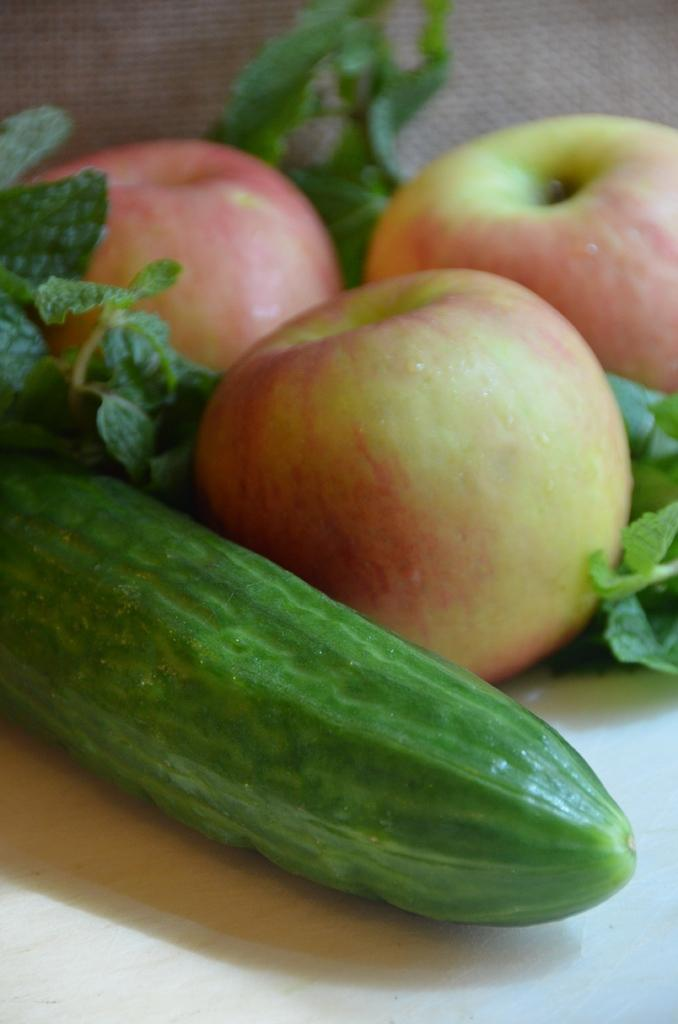What type of fruit can be seen in the image? There are apples in the image. What other type of vegetable is present in the image? There is cucumber in the image. What kind of vegetables with leaves can be seen in the image? There are leafy vegetables in the image. What is the color of the surface on which the items are placed? The surface on which the items are placed is white. What type of cemetery can be seen in the image? There is no cemetery present in the image; it features apples, cucumber, and leafy vegetables on a white surface. 